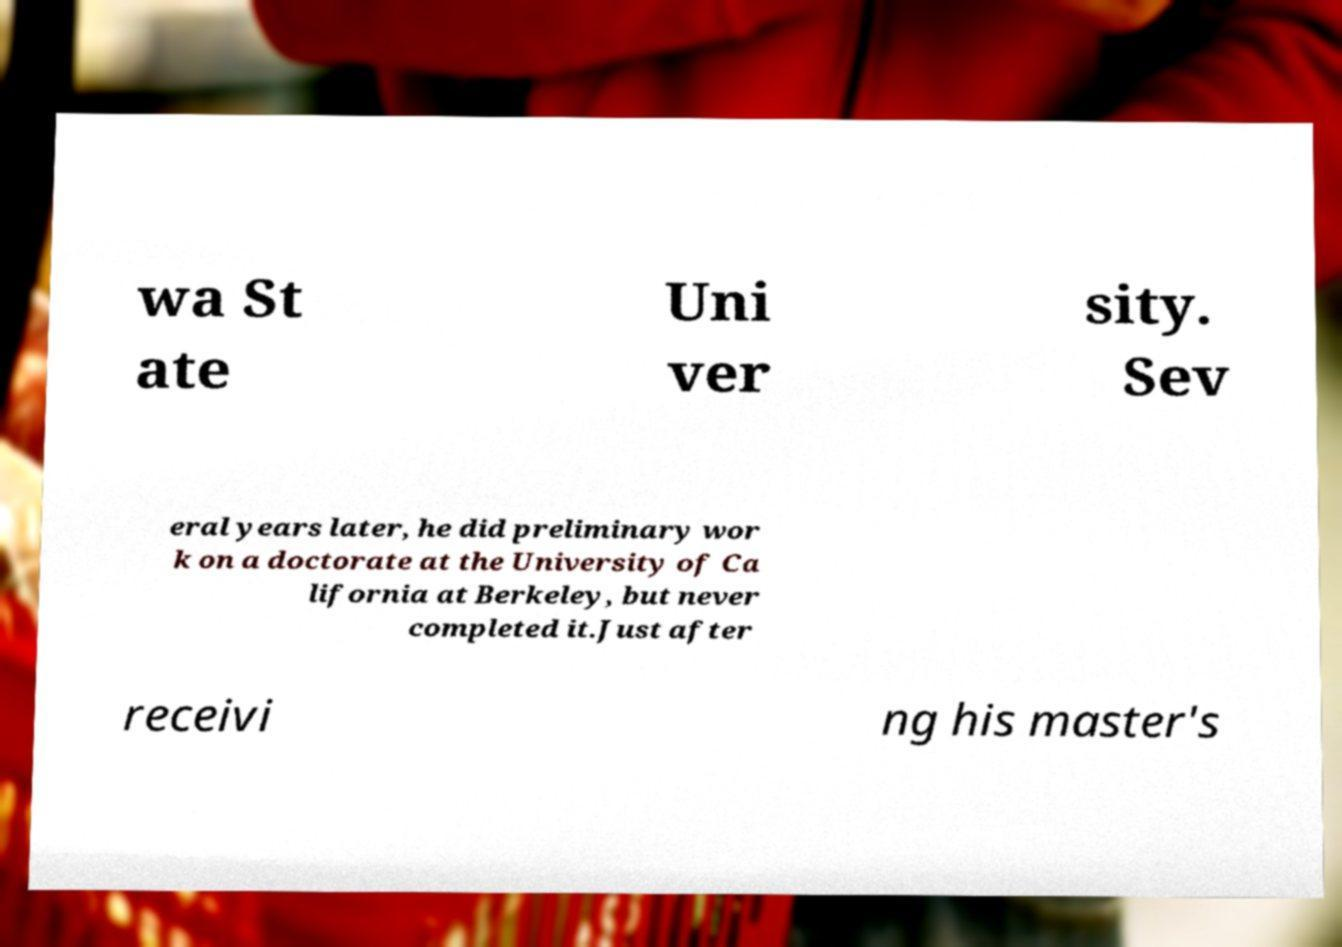Please identify and transcribe the text found in this image. wa St ate Uni ver sity. Sev eral years later, he did preliminary wor k on a doctorate at the University of Ca lifornia at Berkeley, but never completed it.Just after receivi ng his master's 